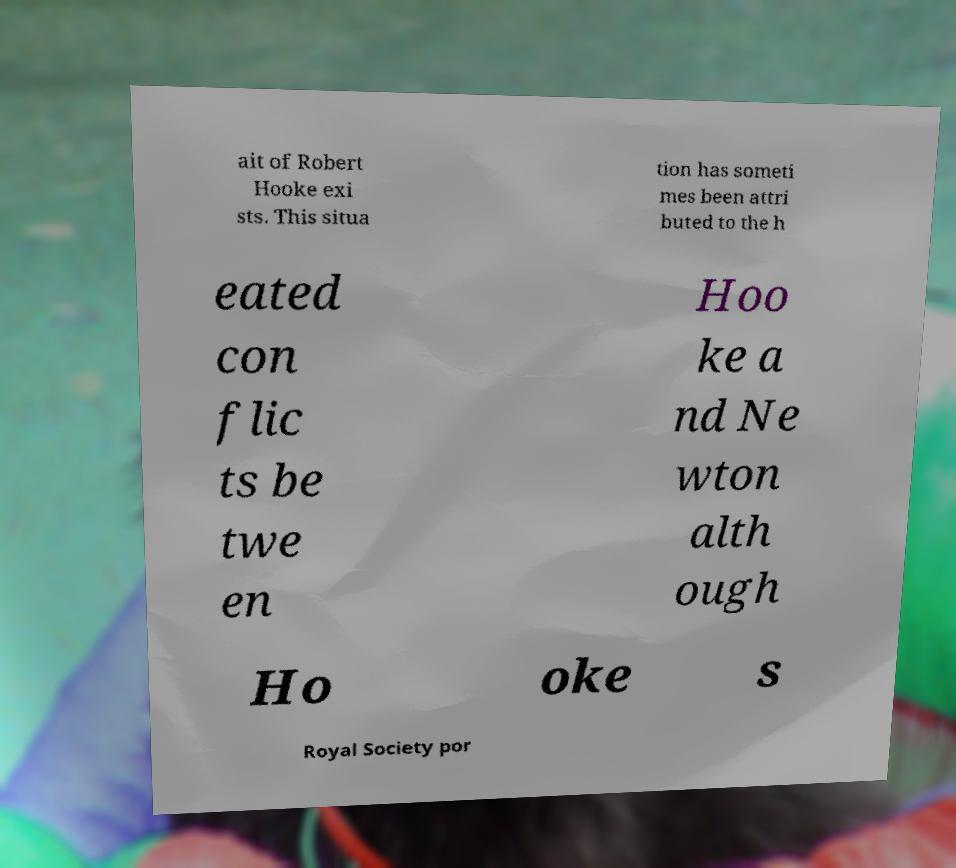Please read and relay the text visible in this image. What does it say? ait of Robert Hooke exi sts. This situa tion has someti mes been attri buted to the h eated con flic ts be twe en Hoo ke a nd Ne wton alth ough Ho oke s Royal Society por 